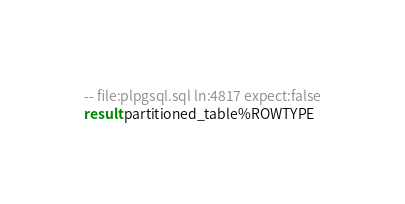Convert code to text. <code><loc_0><loc_0><loc_500><loc_500><_SQL_>-- file:plpgsql.sql ln:4817 expect:false
result partitioned_table%ROWTYPE
</code> 